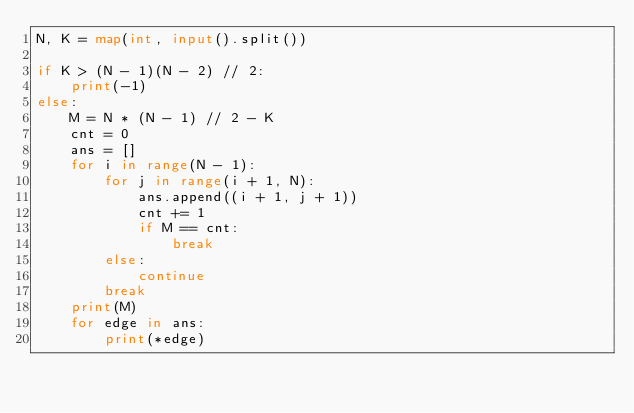<code> <loc_0><loc_0><loc_500><loc_500><_Python_>N, K = map(int, input().split())

if K > (N - 1)(N - 2) // 2:
    print(-1)
else:
    M = N * (N - 1) // 2 - K
    cnt = 0
    ans = []
    for i in range(N - 1):
        for j in range(i + 1, N):
            ans.append((i + 1, j + 1))
            cnt += 1
            if M == cnt:
                break
        else:
            continue
        break
    print(M)
    for edge in ans:
        print(*edge)
</code> 